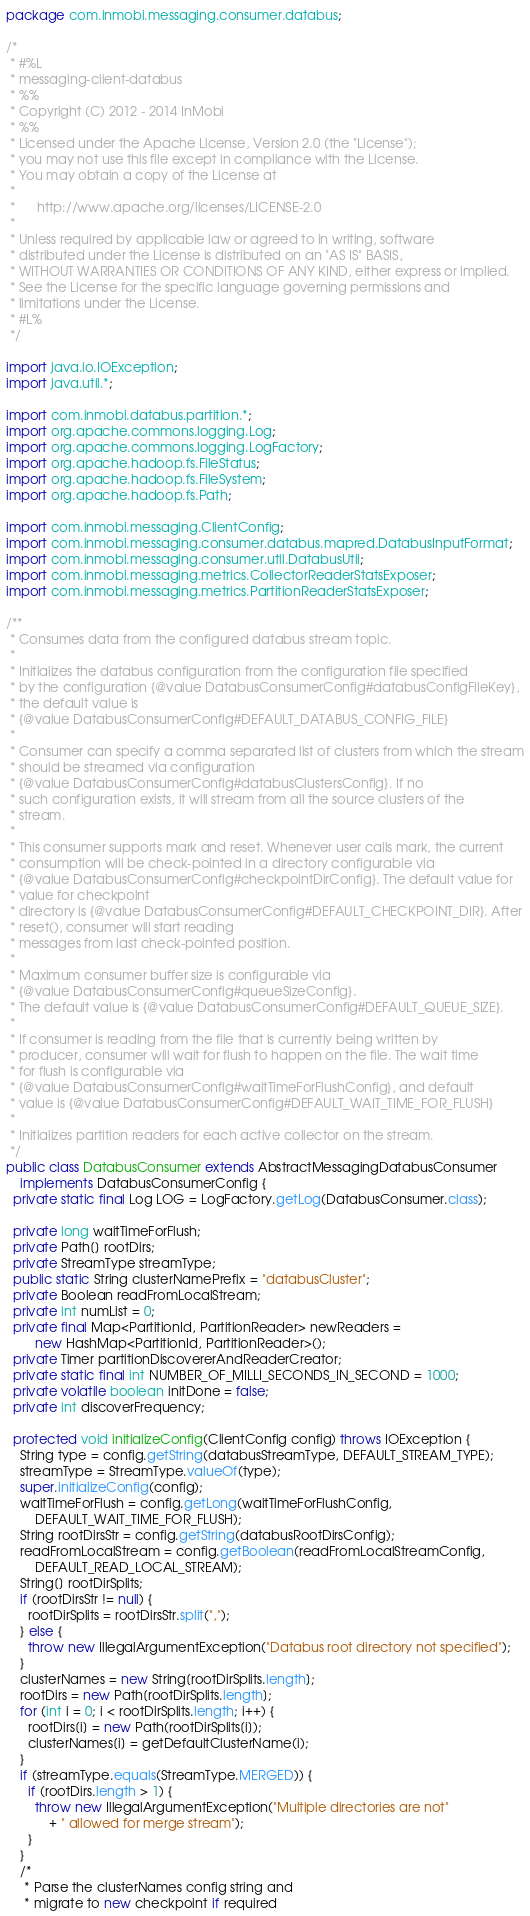<code> <loc_0><loc_0><loc_500><loc_500><_Java_>package com.inmobi.messaging.consumer.databus;

/*
 * #%L
 * messaging-client-databus
 * %%
 * Copyright (C) 2012 - 2014 InMobi
 * %%
 * Licensed under the Apache License, Version 2.0 (the "License");
 * you may not use this file except in compliance with the License.
 * You may obtain a copy of the License at
 * 
 *      http://www.apache.org/licenses/LICENSE-2.0
 * 
 * Unless required by applicable law or agreed to in writing, software
 * distributed under the License is distributed on an "AS IS" BASIS,
 * WITHOUT WARRANTIES OR CONDITIONS OF ANY KIND, either express or implied.
 * See the License for the specific language governing permissions and
 * limitations under the License.
 * #L%
 */

import java.io.IOException;
import java.util.*;

import com.inmobi.databus.partition.*;
import org.apache.commons.logging.Log;
import org.apache.commons.logging.LogFactory;
import org.apache.hadoop.fs.FileStatus;
import org.apache.hadoop.fs.FileSystem;
import org.apache.hadoop.fs.Path;

import com.inmobi.messaging.ClientConfig;
import com.inmobi.messaging.consumer.databus.mapred.DatabusInputFormat;
import com.inmobi.messaging.consumer.util.DatabusUtil;
import com.inmobi.messaging.metrics.CollectorReaderStatsExposer;
import com.inmobi.messaging.metrics.PartitionReaderStatsExposer;

/**
 * Consumes data from the configured databus stream topic.
 *
 * Initializes the databus configuration from the configuration file specified
 * by the configuration {@value DatabusConsumerConfig#databusConfigFileKey},
 * the default value is
 * {@value DatabusConsumerConfig#DEFAULT_DATABUS_CONFIG_FILE}
 *
 * Consumer can specify a comma separated list of clusters from which the stream
 * should be streamed via configuration
 * {@value DatabusConsumerConfig#databusClustersConfig}. If no
 * such configuration exists, it will stream from all the source clusters of the
 * stream.
 *
 * This consumer supports mark and reset. Whenever user calls mark, the current
 * consumption will be check-pointed in a directory configurable via
 * {@value DatabusConsumerConfig#checkpointDirConfig}. The default value for
 * value for checkpoint
 * directory is {@value DatabusConsumerConfig#DEFAULT_CHECKPOINT_DIR}. After
 * reset(), consumer will start reading
 * messages from last check-pointed position.
 *
 * Maximum consumer buffer size is configurable via
 * {@value DatabusConsumerConfig#queueSizeConfig}.
 * The default value is {@value DatabusConsumerConfig#DEFAULT_QUEUE_SIZE}.
 *
 * If consumer is reading from the file that is currently being written by
 * producer, consumer will wait for flush to happen on the file. The wait time
 * for flush is configurable via
 * {@value DatabusConsumerConfig#waitTimeForFlushConfig}, and default
 * value is {@value DatabusConsumerConfig#DEFAULT_WAIT_TIME_FOR_FLUSH}
 *
 * Initializes partition readers for each active collector on the stream.
 */
public class DatabusConsumer extends AbstractMessagingDatabusConsumer
    implements DatabusConsumerConfig {
  private static final Log LOG = LogFactory.getLog(DatabusConsumer.class);

  private long waitTimeForFlush;
  private Path[] rootDirs;
  private StreamType streamType;
  public static String clusterNamePrefix = "databusCluster";
  private Boolean readFromLocalStream;
  private int numList = 0;
  private final Map<PartitionId, PartitionReader> newReaders =
        new HashMap<PartitionId, PartitionReader>();
  private Timer partitionDiscovererAndReaderCreator;
  private static final int NUMBER_OF_MILLI_SECONDS_IN_SECOND = 1000;
  private volatile boolean initDone = false;
  private int discoverFrequency;

  protected void initializeConfig(ClientConfig config) throws IOException {
    String type = config.getString(databusStreamType, DEFAULT_STREAM_TYPE);
    streamType = StreamType.valueOf(type);
    super.initializeConfig(config);
    waitTimeForFlush = config.getLong(waitTimeForFlushConfig,
        DEFAULT_WAIT_TIME_FOR_FLUSH);
    String rootDirsStr = config.getString(databusRootDirsConfig);
    readFromLocalStream = config.getBoolean(readFromLocalStreamConfig,
        DEFAULT_READ_LOCAL_STREAM);
    String[] rootDirSplits;
    if (rootDirsStr != null) {
      rootDirSplits = rootDirsStr.split(",");
    } else {
      throw new IllegalArgumentException("Databus root directory not specified");
    }
    clusterNames = new String[rootDirSplits.length];
    rootDirs = new Path[rootDirSplits.length];
    for (int i = 0; i < rootDirSplits.length; i++) {
      rootDirs[i] = new Path(rootDirSplits[i]);
      clusterNames[i] = getDefaultClusterName(i);
    }
    if (streamType.equals(StreamType.MERGED)) {
      if (rootDirs.length > 1) {
        throw new IllegalArgumentException("Multiple directories are not"
            + " allowed for merge stream");
      }
    }
    /*
     * Parse the clusterNames config string and
     * migrate to new checkpoint if required</code> 